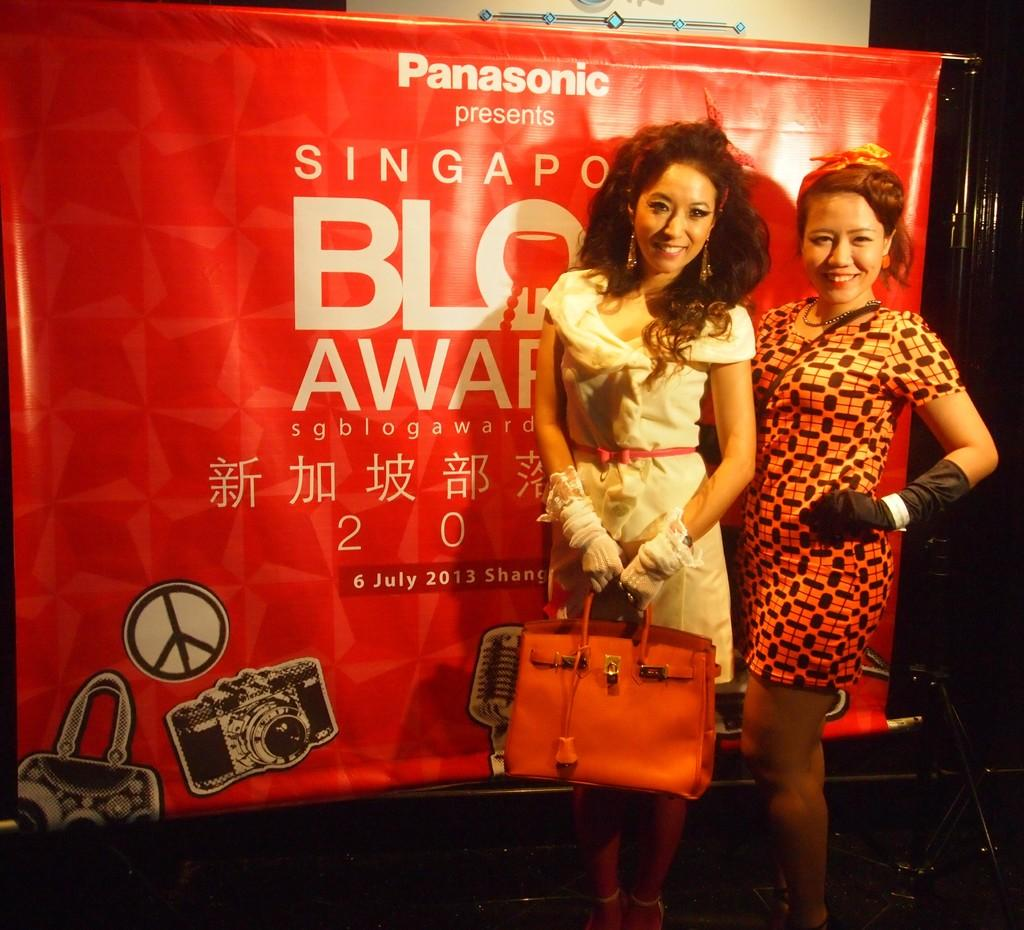How many people are present in the image? There are two people standing in the image. Where are the people located in the image? The people are on the right side of the image. What can be seen in the background of the image? There is a red color poster in the background of the image. What type of wound can be seen on the cloth in the image? There is no cloth or wound present in the image. What type of meal are the people eating in the image? There is no meal visible in the image; the focus is on the two people standing on the right side. 